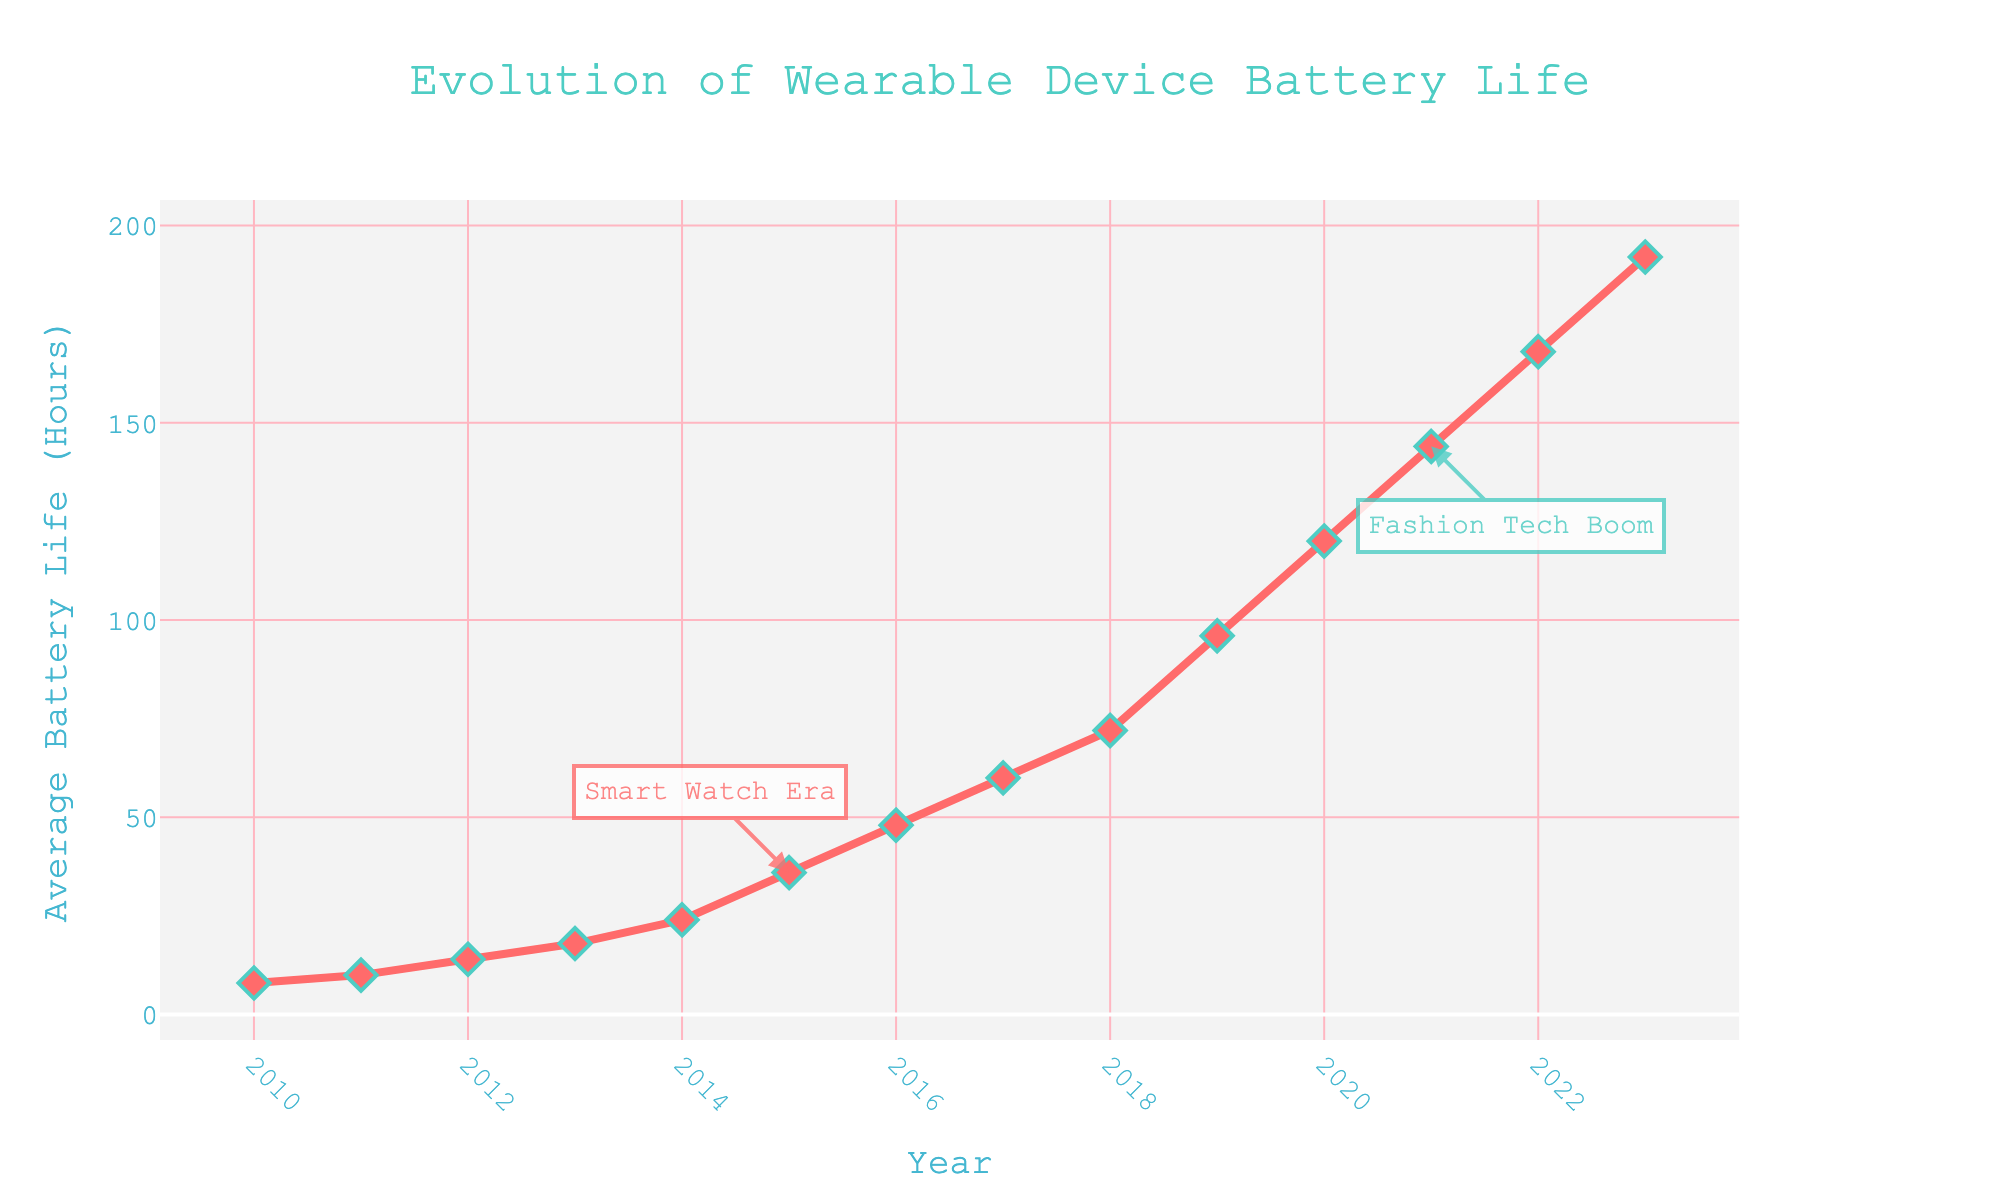What year marks the beginning of the "Fashion Tech Boom"? The figure has an annotation that indicates the "Fashion Tech Boom" starting point, which is visually positioned at 2021.
Answer: 2021 How much did the average battery life improve from 2010 to 2015? The average battery life in 2010 was 8 hours, and in 2015 it was 36 hours. Subtract 8 from 36 to find the improvement.
Answer: 28 hours What is the average battery life in 2018 compared to 2022? Refer to the figure and look at the respective points for 2018 and 2022. In 2018 it is 72 hours, and in 2022 it is 168 hours.
Answer: 72 hours vs 168 hours Which year saw the average battery life double from the previous year between 2015 and 2017? In the figure, follow the years from 2015 to 2017 and check the battery life values: 2015 (36), 2016 (48), 2017 (60). There is no doubling in this period, so none of these years meet the condition.
Answer: None What trend is observed in the battery life from 2010 to 2023? Looking at the line graph, there is a clear upward trend showing a continuous increase in the average battery life of wearable devices from 2010 (8 hours) to 2023 (192 hours).
Answer: Continuous increase In which year was the average battery life 120 hours? Find the specific data point labeled 120 hours on the y-axis and trace it to the corresponding year on the x-axis. The year is 2020.
Answer: 2020 How much has the average battery life increased per year on average from 2010 to 2023? Calculate the difference between the average battery life in 2023 (192 hours) and 2010 (8 hours), which is 184 hours. Divide this by the number of years (2023 - 2010 = 13 years) to get the average increase per year.
Answer: 14.15 hours/year At what year did the ‘Smart Watch Era’ annotation get marked and what was the corresponding average battery life? The 'Smart Watch Era' annotation is placed at the year 2015 with an average battery life of 36 hours.
Answer: 2015, 36 hours Comparing the battery life from 2013 to 2014, how much was the increase in terms of hours and percentage? The average battery life in 2013 was 18 hours, and in 2014 it was 24 hours. The increase in hours is 24 - 18 = 6 hours. The percentage increase is (6/18)*100 = 33.33%.
Answer: 6 hours, 33.33% Which years have average battery life data points that are marked with annotations on the figure? From the visual information, the years with annotations are 2015 ('Smart Watch Era') and 2021 ('Fashion Tech Boom').
Answer: 2015, 2021 